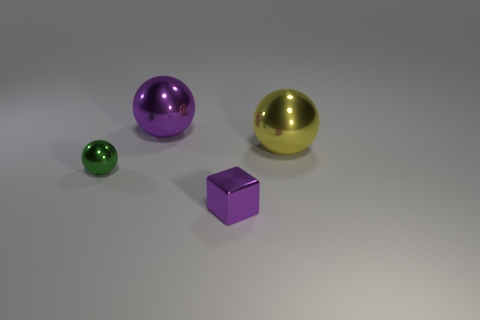What can you infer about the size of these objects in relation to each other? The three spheres and the cube vary in size, creating a sense of scale. The green sphere is the smallest, followed by the purple cube, the purple sphere is larger, and the gold sphere is the largest of them all. This scaling can suggest a progression or hierarchy in size, conveying depth in the image.  Can you imagine a real-world use for these objects if they were actual size? If the objects were actual size, the spheres could be decorative ornaments or part of a larger artistic installation, given their reflective, aesthetic nature. The cube might serve a practical purpose as a paperweight or a stylistic desktop object. 